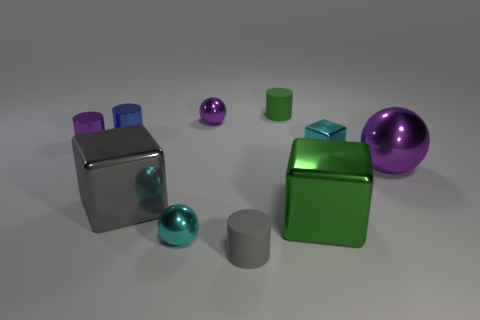What number of other things are there of the same color as the large metal ball?
Ensure brevity in your answer.  2. What is the size of the gray object that is in front of the shiny block that is in front of the big gray metallic block?
Your response must be concise. Small. Are the large cube right of the small gray object and the purple sphere behind the large purple thing made of the same material?
Keep it short and to the point. Yes. There is a metallic sphere that is behind the small cyan metal block; does it have the same color as the large metallic sphere?
Provide a succinct answer. Yes. How many tiny gray cylinders are left of the tiny gray rubber cylinder?
Offer a terse response. 0. Do the big gray thing and the small cyan cube in front of the green cylinder have the same material?
Your answer should be very brief. Yes. There is a cyan cube that is made of the same material as the tiny blue object; what size is it?
Keep it short and to the point. Small. Are there more big shiny things to the right of the tiny gray matte cylinder than purple objects that are behind the big purple sphere?
Make the answer very short. No. Is there a matte thing that has the same shape as the small blue metallic object?
Your answer should be very brief. Yes. Does the cyan sphere in front of the cyan metal cube have the same size as the big purple metal sphere?
Provide a succinct answer. No. 